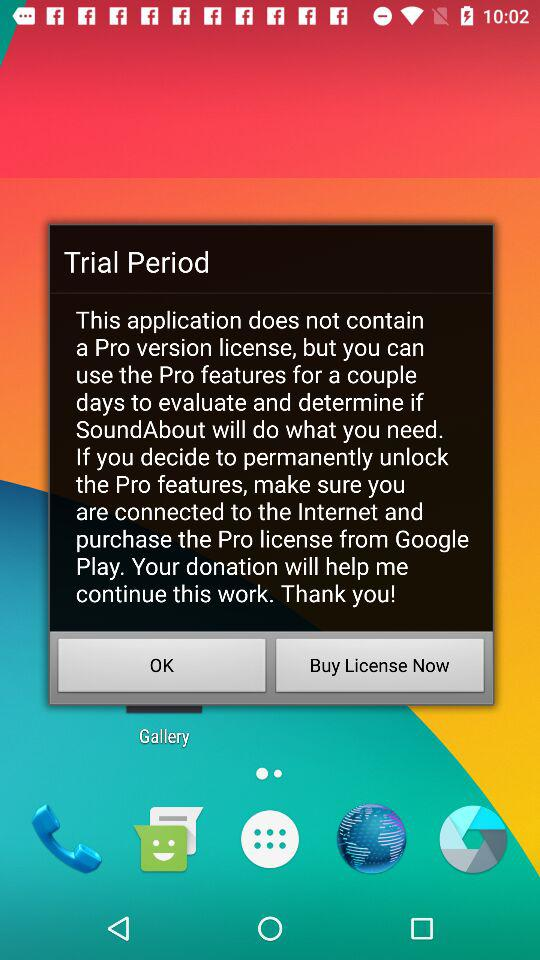From where can we purchase the Pro version license? You can purchase the Pro version license from "Google Play". 